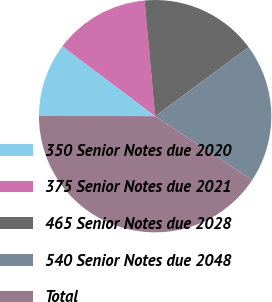<chart> <loc_0><loc_0><loc_500><loc_500><pie_chart><fcel>350 Senior Notes due 2020<fcel>375 Senior Notes due 2021<fcel>465 Senior Notes due 2028<fcel>540 Senior Notes due 2048<fcel>Total<nl><fcel>10.2%<fcel>13.27%<fcel>16.33%<fcel>19.39%<fcel>40.82%<nl></chart> 